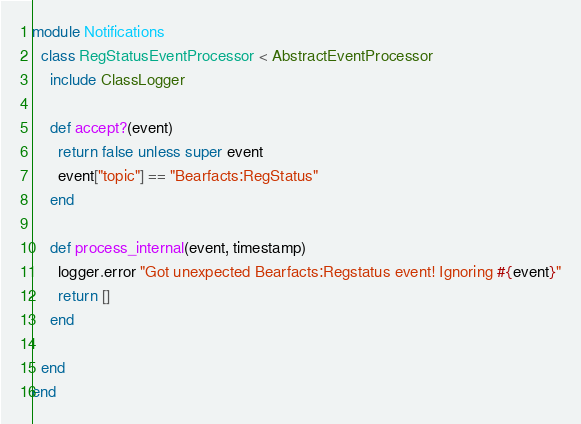Convert code to text. <code><loc_0><loc_0><loc_500><loc_500><_Ruby_>module Notifications
  class RegStatusEventProcessor < AbstractEventProcessor
    include ClassLogger

    def accept?(event)
      return false unless super event
      event["topic"] == "Bearfacts:RegStatus"
    end

    def process_internal(event, timestamp)
      logger.error "Got unexpected Bearfacts:Regstatus event! Ignoring #{event}"
      return []
    end

  end
end
</code> 